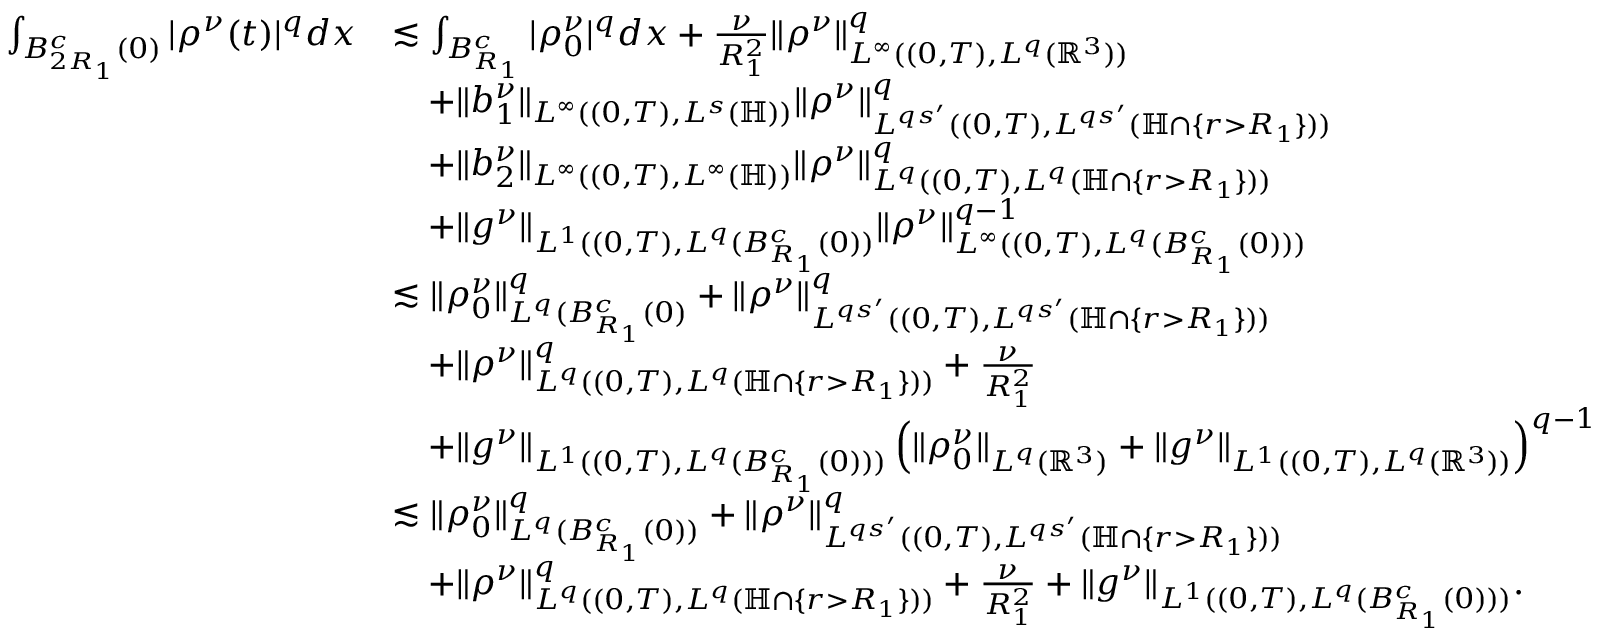Convert formula to latex. <formula><loc_0><loc_0><loc_500><loc_500>\begin{array} { r l } { \int _ { B _ { 2 R _ { 1 } } ^ { c } ( 0 ) } | \rho ^ { \nu } ( t ) | ^ { q } d x } & { \lesssim \int _ { B _ { R _ { 1 } } ^ { c } } | \rho _ { 0 } ^ { \nu } | ^ { q } d x + \frac { \nu } { R _ { 1 } ^ { 2 } } \| \rho ^ { \nu } \| _ { L ^ { \infty } ( ( 0 , T ) , L ^ { q } ( \mathbb { R } ^ { 3 } ) ) } ^ { q } } \\ & { \quad + \| b _ { 1 } ^ { \nu } \| _ { L ^ { \infty } ( ( 0 , T ) , L ^ { s } ( \mathbb { H } ) ) } \| \rho ^ { \nu } \| _ { L ^ { q s ^ { \prime } } ( ( 0 , T ) , L ^ { q s ^ { \prime } } ( \mathbb { H } \cap \{ r > R _ { 1 } \} ) ) } ^ { q } } \\ & { \quad + \| b _ { 2 } ^ { \nu } \| _ { L ^ { \infty } ( ( 0 , T ) , L ^ { \infty } ( \mathbb { H } ) ) } \| \rho ^ { \nu } \| _ { L ^ { q } ( ( 0 , T ) , L ^ { q } ( \mathbb { H } \cap \{ r > R _ { 1 } \} ) ) } ^ { q } } \\ & { \quad + \| g ^ { \nu } \| _ { L ^ { 1 } ( ( 0 , T ) , L ^ { q } ( B _ { R _ { 1 } } ^ { c } ( 0 ) ) } \| \rho ^ { \nu } \| _ { L ^ { \infty } ( ( 0 , T ) , L ^ { q } ( B _ { R _ { 1 } } ^ { c } ( 0 ) ) ) } ^ { q - 1 } } \\ & { \lesssim \| \rho _ { 0 } ^ { \nu } \| _ { L ^ { q } ( B _ { R _ { 1 } } ^ { c } ( 0 ) } ^ { q } + \| \rho ^ { \nu } \| _ { L ^ { q s ^ { \prime } } ( ( 0 , T ) , L ^ { q s ^ { \prime } } ( \mathbb { H } \cap \{ r > R _ { 1 } \} ) ) } ^ { q } } \\ & { \quad + \| \rho ^ { \nu } \| _ { L ^ { q } ( ( 0 , T ) , L ^ { q } ( \mathbb { H } \cap \{ r > R _ { 1 } \} ) ) } ^ { q } + \frac { \nu } { R _ { 1 } ^ { 2 } } } \\ & { \quad + \| g ^ { \nu } \| _ { L ^ { 1 } ( ( 0 , T ) , L ^ { q } ( B _ { R _ { 1 } } ^ { c } ( 0 ) ) ) } \left ( \| \rho _ { 0 } ^ { \nu } \| _ { L ^ { q } ( \mathbb { R } ^ { 3 } ) } + \| g ^ { \nu } \| _ { L ^ { 1 } ( ( 0 , T ) , L ^ { q } ( \mathbb { R } ^ { 3 } ) ) } \right ) ^ { q - 1 } } \\ & { \lesssim \| \rho _ { 0 } ^ { \nu } \| _ { L ^ { q } ( B _ { R _ { 1 } } ^ { c } ( 0 ) ) } ^ { q } + \| \rho ^ { \nu } \| _ { L ^ { q s ^ { \prime } } ( ( 0 , T ) , L ^ { q s ^ { \prime } } ( \mathbb { H } \cap \{ r > R _ { 1 } \} ) ) } ^ { q } } \\ & { \quad + \| \rho ^ { \nu } \| _ { L ^ { q } ( ( 0 , T ) , L ^ { q } ( \mathbb { H } \cap \{ r > R _ { 1 } \} ) ) } ^ { q } + \frac { \nu } { R _ { 1 } ^ { 2 } } + \| g ^ { \nu } \| _ { L ^ { 1 } ( ( 0 , T ) , L ^ { q } ( B _ { R _ { 1 } } ^ { c } ( 0 ) ) ) } . } \end{array}</formula> 